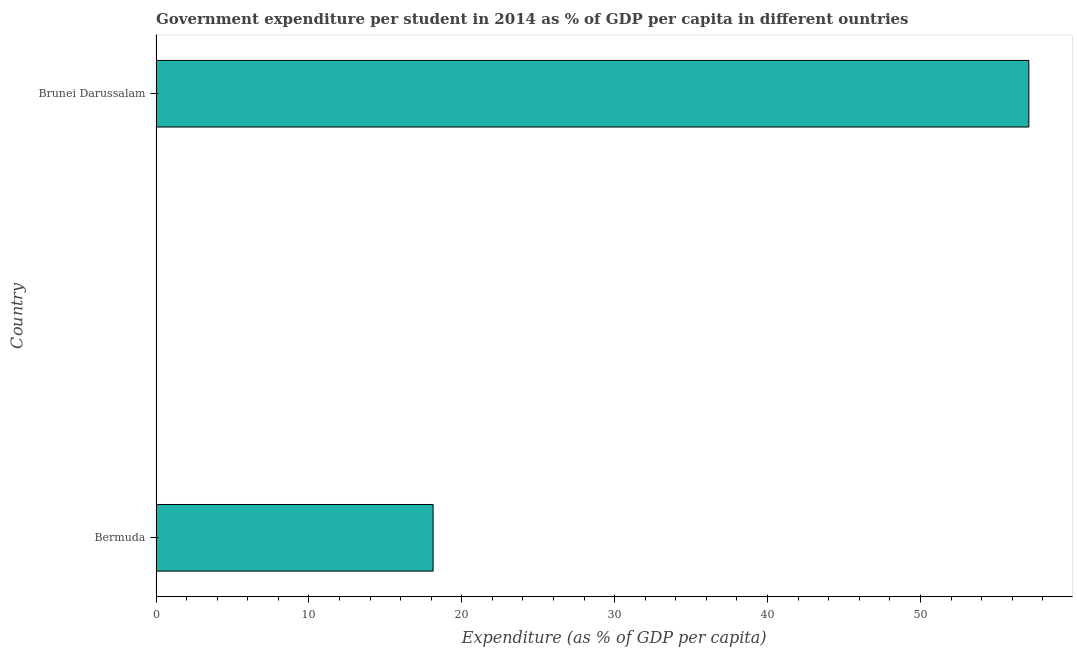Does the graph contain grids?
Provide a short and direct response. No. What is the title of the graph?
Make the answer very short. Government expenditure per student in 2014 as % of GDP per capita in different ountries. What is the label or title of the X-axis?
Keep it short and to the point. Expenditure (as % of GDP per capita). What is the label or title of the Y-axis?
Give a very brief answer. Country. What is the government expenditure per student in Brunei Darussalam?
Give a very brief answer. 57.09. Across all countries, what is the maximum government expenditure per student?
Provide a succinct answer. 57.09. Across all countries, what is the minimum government expenditure per student?
Your response must be concise. 18.12. In which country was the government expenditure per student maximum?
Offer a terse response. Brunei Darussalam. In which country was the government expenditure per student minimum?
Keep it short and to the point. Bermuda. What is the sum of the government expenditure per student?
Offer a terse response. 75.22. What is the difference between the government expenditure per student in Bermuda and Brunei Darussalam?
Keep it short and to the point. -38.97. What is the average government expenditure per student per country?
Provide a short and direct response. 37.61. What is the median government expenditure per student?
Provide a succinct answer. 37.61. What is the ratio of the government expenditure per student in Bermuda to that in Brunei Darussalam?
Provide a succinct answer. 0.32. How many bars are there?
Keep it short and to the point. 2. Are all the bars in the graph horizontal?
Provide a succinct answer. Yes. How many countries are there in the graph?
Your answer should be compact. 2. What is the difference between two consecutive major ticks on the X-axis?
Offer a terse response. 10. Are the values on the major ticks of X-axis written in scientific E-notation?
Provide a short and direct response. No. What is the Expenditure (as % of GDP per capita) of Bermuda?
Your answer should be very brief. 18.12. What is the Expenditure (as % of GDP per capita) in Brunei Darussalam?
Your answer should be compact. 57.09. What is the difference between the Expenditure (as % of GDP per capita) in Bermuda and Brunei Darussalam?
Your answer should be very brief. -38.97. What is the ratio of the Expenditure (as % of GDP per capita) in Bermuda to that in Brunei Darussalam?
Your answer should be compact. 0.32. 